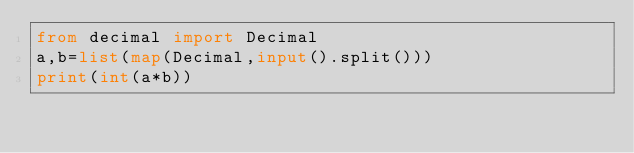<code> <loc_0><loc_0><loc_500><loc_500><_Python_>from decimal import Decimal
a,b=list(map(Decimal,input().split()))
print(int(a*b))</code> 